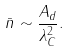<formula> <loc_0><loc_0><loc_500><loc_500>\bar { n } \sim \frac { A _ { d } } { \lambda _ { C } ^ { 2 } } .</formula> 